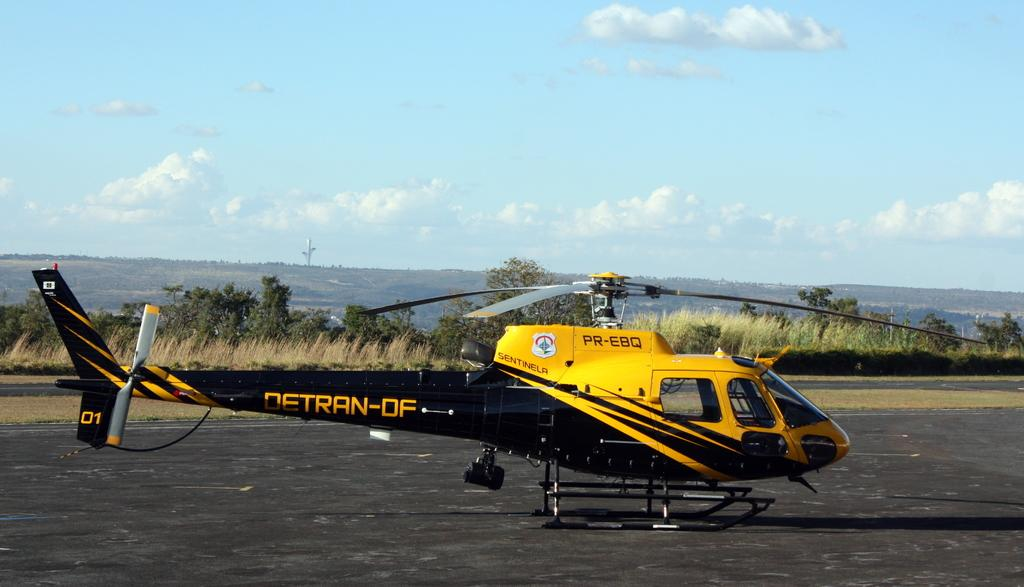<image>
Present a compact description of the photo's key features. A black and yellow helicopter has the word Detran written on the tail. 